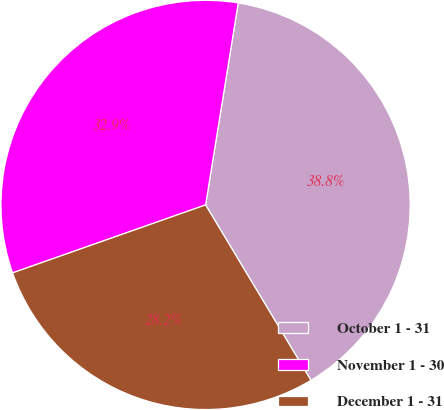Convert chart. <chart><loc_0><loc_0><loc_500><loc_500><pie_chart><fcel>October 1 - 31<fcel>November 1 - 30<fcel>December 1 - 31<nl><fcel>38.84%<fcel>32.94%<fcel>28.22%<nl></chart> 